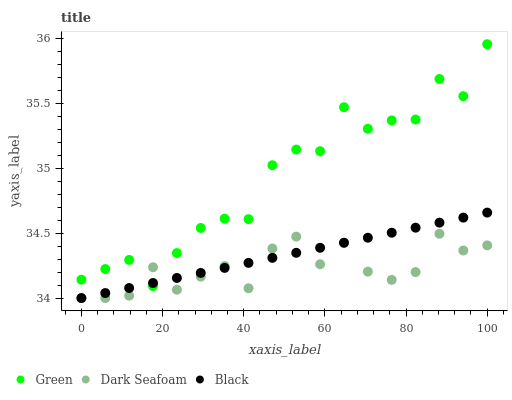Does Dark Seafoam have the minimum area under the curve?
Answer yes or no. Yes. Does Green have the maximum area under the curve?
Answer yes or no. Yes. Does Green have the minimum area under the curve?
Answer yes or no. No. Does Dark Seafoam have the maximum area under the curve?
Answer yes or no. No. Is Black the smoothest?
Answer yes or no. Yes. Is Green the roughest?
Answer yes or no. Yes. Is Dark Seafoam the smoothest?
Answer yes or no. No. Is Dark Seafoam the roughest?
Answer yes or no. No. Does Black have the lowest value?
Answer yes or no. Yes. Does Green have the lowest value?
Answer yes or no. No. Does Green have the highest value?
Answer yes or no. Yes. Does Dark Seafoam have the highest value?
Answer yes or no. No. Does Green intersect Black?
Answer yes or no. Yes. Is Green less than Black?
Answer yes or no. No. Is Green greater than Black?
Answer yes or no. No. 